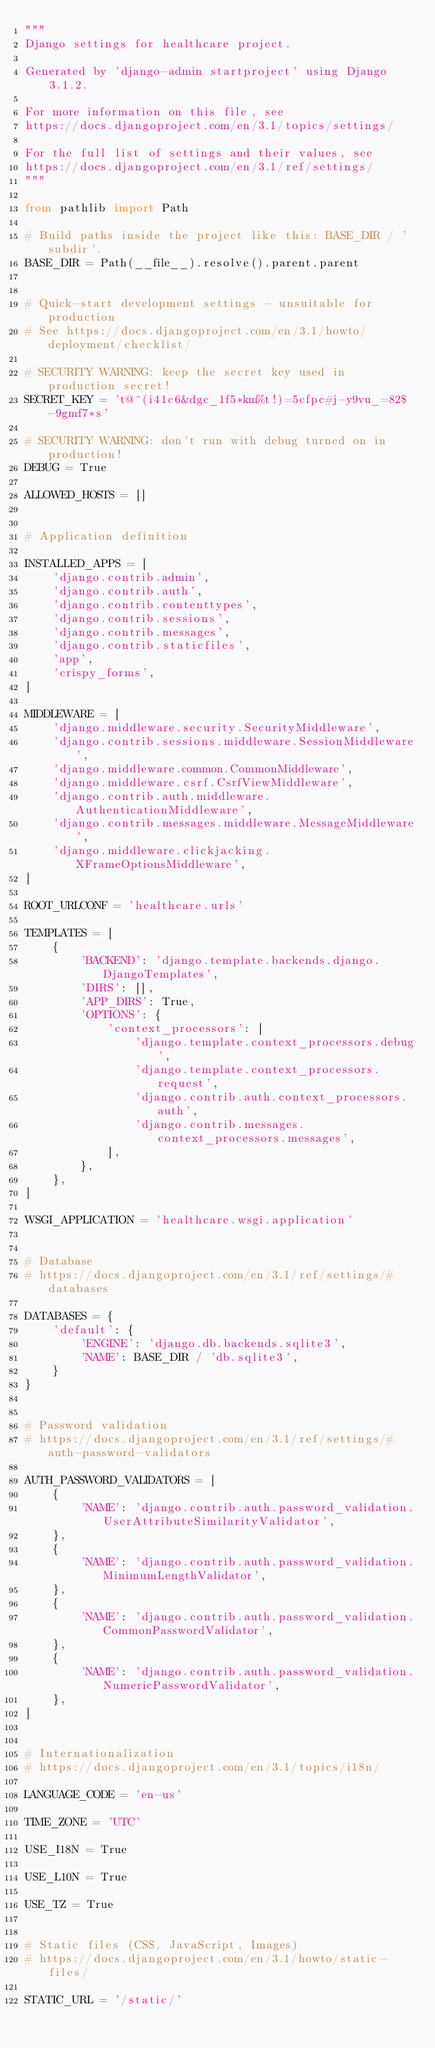Convert code to text. <code><loc_0><loc_0><loc_500><loc_500><_Python_>"""
Django settings for healthcare project.

Generated by 'django-admin startproject' using Django 3.1.2.

For more information on this file, see
https://docs.djangoproject.com/en/3.1/topics/settings/

For the full list of settings and their values, see
https://docs.djangoproject.com/en/3.1/ref/settings/
"""

from pathlib import Path

# Build paths inside the project like this: BASE_DIR / 'subdir'.
BASE_DIR = Path(__file__).resolve().parent.parent


# Quick-start development settings - unsuitable for production
# See https://docs.djangoproject.com/en/3.1/howto/deployment/checklist/

# SECURITY WARNING: keep the secret key used in production secret!
SECRET_KEY = 't@^(i41c6&dgc_1f5*km%t!)=5cfpc#j-y9vu_=82$-9gmf7*s'

# SECURITY WARNING: don't run with debug turned on in production!
DEBUG = True

ALLOWED_HOSTS = []


# Application definition

INSTALLED_APPS = [
    'django.contrib.admin',
    'django.contrib.auth',
    'django.contrib.contenttypes',
    'django.contrib.sessions',
    'django.contrib.messages',
    'django.contrib.staticfiles',
    'app',
    'crispy_forms',
]

MIDDLEWARE = [
    'django.middleware.security.SecurityMiddleware',
    'django.contrib.sessions.middleware.SessionMiddleware',
    'django.middleware.common.CommonMiddleware',
    'django.middleware.csrf.CsrfViewMiddleware',
    'django.contrib.auth.middleware.AuthenticationMiddleware',
    'django.contrib.messages.middleware.MessageMiddleware',
    'django.middleware.clickjacking.XFrameOptionsMiddleware',
]

ROOT_URLCONF = 'healthcare.urls'

TEMPLATES = [
    {
        'BACKEND': 'django.template.backends.django.DjangoTemplates',
        'DIRS': [],
        'APP_DIRS': True,
        'OPTIONS': {
            'context_processors': [
                'django.template.context_processors.debug',
                'django.template.context_processors.request',
                'django.contrib.auth.context_processors.auth',
                'django.contrib.messages.context_processors.messages',
            ],
        },
    },
]

WSGI_APPLICATION = 'healthcare.wsgi.application'


# Database
# https://docs.djangoproject.com/en/3.1/ref/settings/#databases

DATABASES = {
    'default': {
        'ENGINE': 'django.db.backends.sqlite3',
        'NAME': BASE_DIR / 'db.sqlite3',
    }
}


# Password validation
# https://docs.djangoproject.com/en/3.1/ref/settings/#auth-password-validators

AUTH_PASSWORD_VALIDATORS = [
    {
        'NAME': 'django.contrib.auth.password_validation.UserAttributeSimilarityValidator',
    },
    {
        'NAME': 'django.contrib.auth.password_validation.MinimumLengthValidator',
    },
    {
        'NAME': 'django.contrib.auth.password_validation.CommonPasswordValidator',
    },
    {
        'NAME': 'django.contrib.auth.password_validation.NumericPasswordValidator',
    },
]


# Internationalization
# https://docs.djangoproject.com/en/3.1/topics/i18n/

LANGUAGE_CODE = 'en-us'

TIME_ZONE = 'UTC'

USE_I18N = True

USE_L10N = True

USE_TZ = True


# Static files (CSS, JavaScript, Images)
# https://docs.djangoproject.com/en/3.1/howto/static-files/

STATIC_URL = '/static/'
</code> 